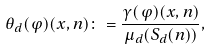<formula> <loc_0><loc_0><loc_500><loc_500>\theta _ { d } ( \varphi ) ( x , n ) \colon = \frac { \gamma ( \varphi ) ( x , n ) } { \mu _ { d } ( S _ { d } ( n ) ) } ,</formula> 